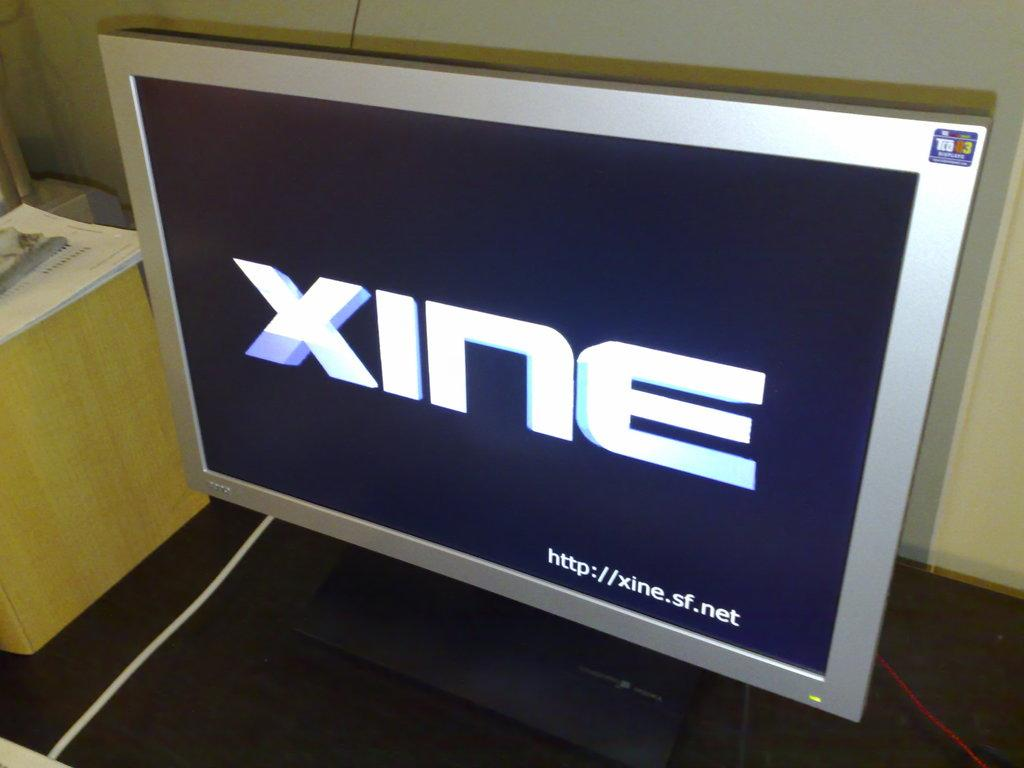<image>
Create a compact narrative representing the image presented. A computer monitor on a desk that has the word XINE on the screen. 